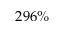Convert formula to latex. <formula><loc_0><loc_0><loc_500><loc_500>2 9 6 \%</formula> 